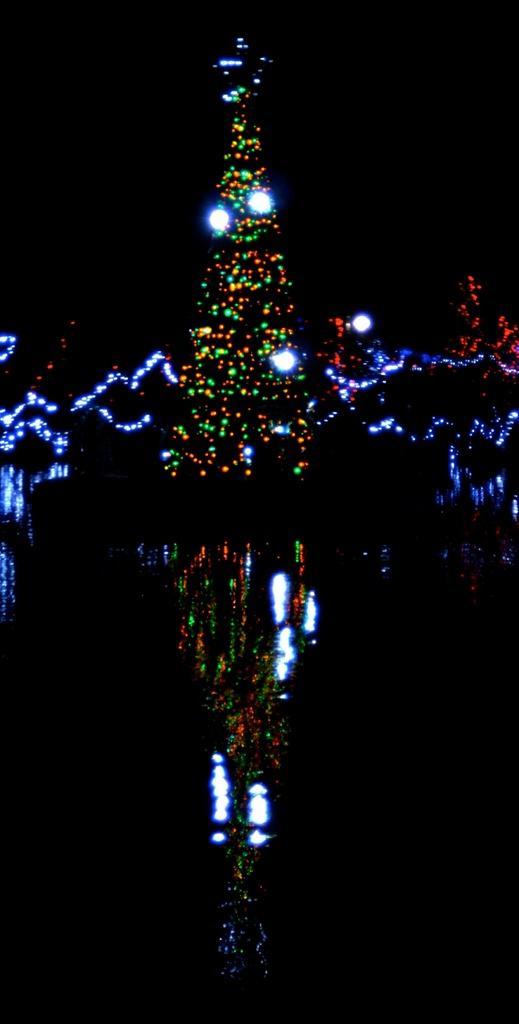Can you describe this image briefly? In this image I can see a tree with lights. And I can see the reflection of the tree in the down. And there is a black background. 